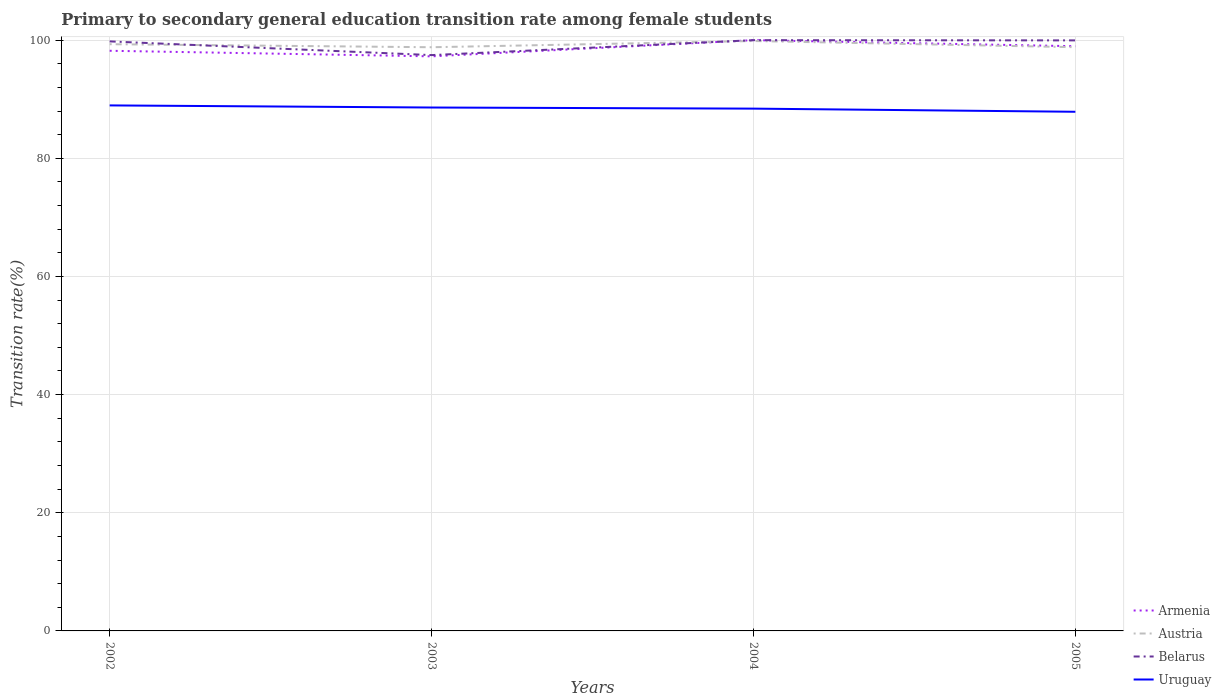Does the line corresponding to Austria intersect with the line corresponding to Armenia?
Your response must be concise. Yes. Is the number of lines equal to the number of legend labels?
Your answer should be compact. Yes. Across all years, what is the maximum transition rate in Belarus?
Ensure brevity in your answer.  97.47. In which year was the transition rate in Uruguay maximum?
Your answer should be compact. 2005. What is the total transition rate in Armenia in the graph?
Provide a succinct answer. 0.95. What is the difference between the highest and the second highest transition rate in Austria?
Provide a succinct answer. 1.05. What is the difference between the highest and the lowest transition rate in Belarus?
Your answer should be very brief. 3. What is the difference between two consecutive major ticks on the Y-axis?
Keep it short and to the point. 20. Does the graph contain any zero values?
Offer a terse response. No. What is the title of the graph?
Your answer should be compact. Primary to secondary general education transition rate among female students. What is the label or title of the Y-axis?
Provide a short and direct response. Transition rate(%). What is the Transition rate(%) in Armenia in 2002?
Your answer should be very brief. 98.2. What is the Transition rate(%) of Austria in 2002?
Ensure brevity in your answer.  99.32. What is the Transition rate(%) of Belarus in 2002?
Ensure brevity in your answer.  99.79. What is the Transition rate(%) of Uruguay in 2002?
Ensure brevity in your answer.  88.96. What is the Transition rate(%) of Armenia in 2003?
Offer a very short reply. 97.26. What is the Transition rate(%) of Austria in 2003?
Provide a succinct answer. 98.8. What is the Transition rate(%) in Belarus in 2003?
Keep it short and to the point. 97.47. What is the Transition rate(%) in Uruguay in 2003?
Provide a short and direct response. 88.6. What is the Transition rate(%) in Austria in 2004?
Ensure brevity in your answer.  99.85. What is the Transition rate(%) in Uruguay in 2004?
Keep it short and to the point. 88.41. What is the Transition rate(%) in Armenia in 2005?
Your answer should be very brief. 98.97. What is the Transition rate(%) in Austria in 2005?
Ensure brevity in your answer.  98.81. What is the Transition rate(%) in Belarus in 2005?
Keep it short and to the point. 99.96. What is the Transition rate(%) in Uruguay in 2005?
Keep it short and to the point. 87.88. Across all years, what is the maximum Transition rate(%) in Armenia?
Ensure brevity in your answer.  100. Across all years, what is the maximum Transition rate(%) of Austria?
Provide a succinct answer. 99.85. Across all years, what is the maximum Transition rate(%) of Belarus?
Your response must be concise. 100. Across all years, what is the maximum Transition rate(%) in Uruguay?
Your answer should be compact. 88.96. Across all years, what is the minimum Transition rate(%) in Armenia?
Your answer should be compact. 97.26. Across all years, what is the minimum Transition rate(%) in Austria?
Your answer should be compact. 98.8. Across all years, what is the minimum Transition rate(%) in Belarus?
Make the answer very short. 97.47. Across all years, what is the minimum Transition rate(%) in Uruguay?
Offer a terse response. 87.88. What is the total Transition rate(%) of Armenia in the graph?
Keep it short and to the point. 394.44. What is the total Transition rate(%) of Austria in the graph?
Offer a very short reply. 396.78. What is the total Transition rate(%) of Belarus in the graph?
Your answer should be very brief. 397.22. What is the total Transition rate(%) in Uruguay in the graph?
Offer a terse response. 353.84. What is the difference between the Transition rate(%) of Armenia in 2002 and that in 2003?
Your answer should be very brief. 0.95. What is the difference between the Transition rate(%) in Austria in 2002 and that in 2003?
Ensure brevity in your answer.  0.52. What is the difference between the Transition rate(%) of Belarus in 2002 and that in 2003?
Make the answer very short. 2.32. What is the difference between the Transition rate(%) in Uruguay in 2002 and that in 2003?
Provide a short and direct response. 0.36. What is the difference between the Transition rate(%) of Armenia in 2002 and that in 2004?
Your answer should be very brief. -1.8. What is the difference between the Transition rate(%) of Austria in 2002 and that in 2004?
Offer a very short reply. -0.54. What is the difference between the Transition rate(%) in Belarus in 2002 and that in 2004?
Give a very brief answer. -0.21. What is the difference between the Transition rate(%) of Uruguay in 2002 and that in 2004?
Offer a very short reply. 0.55. What is the difference between the Transition rate(%) of Armenia in 2002 and that in 2005?
Keep it short and to the point. -0.77. What is the difference between the Transition rate(%) of Austria in 2002 and that in 2005?
Ensure brevity in your answer.  0.51. What is the difference between the Transition rate(%) in Belarus in 2002 and that in 2005?
Ensure brevity in your answer.  -0.17. What is the difference between the Transition rate(%) in Uruguay in 2002 and that in 2005?
Ensure brevity in your answer.  1.08. What is the difference between the Transition rate(%) of Armenia in 2003 and that in 2004?
Your answer should be compact. -2.74. What is the difference between the Transition rate(%) of Austria in 2003 and that in 2004?
Provide a succinct answer. -1.05. What is the difference between the Transition rate(%) in Belarus in 2003 and that in 2004?
Your response must be concise. -2.53. What is the difference between the Transition rate(%) of Uruguay in 2003 and that in 2004?
Keep it short and to the point. 0.19. What is the difference between the Transition rate(%) in Armenia in 2003 and that in 2005?
Ensure brevity in your answer.  -1.72. What is the difference between the Transition rate(%) of Austria in 2003 and that in 2005?
Make the answer very short. -0.01. What is the difference between the Transition rate(%) in Belarus in 2003 and that in 2005?
Keep it short and to the point. -2.49. What is the difference between the Transition rate(%) of Uruguay in 2003 and that in 2005?
Offer a very short reply. 0.72. What is the difference between the Transition rate(%) in Armenia in 2004 and that in 2005?
Your answer should be compact. 1.03. What is the difference between the Transition rate(%) of Austria in 2004 and that in 2005?
Keep it short and to the point. 1.05. What is the difference between the Transition rate(%) of Belarus in 2004 and that in 2005?
Your response must be concise. 0.04. What is the difference between the Transition rate(%) of Uruguay in 2004 and that in 2005?
Your answer should be compact. 0.53. What is the difference between the Transition rate(%) in Armenia in 2002 and the Transition rate(%) in Austria in 2003?
Your answer should be very brief. -0.6. What is the difference between the Transition rate(%) of Armenia in 2002 and the Transition rate(%) of Belarus in 2003?
Keep it short and to the point. 0.73. What is the difference between the Transition rate(%) in Armenia in 2002 and the Transition rate(%) in Uruguay in 2003?
Provide a succinct answer. 9.61. What is the difference between the Transition rate(%) of Austria in 2002 and the Transition rate(%) of Belarus in 2003?
Offer a terse response. 1.85. What is the difference between the Transition rate(%) in Austria in 2002 and the Transition rate(%) in Uruguay in 2003?
Your answer should be compact. 10.72. What is the difference between the Transition rate(%) in Belarus in 2002 and the Transition rate(%) in Uruguay in 2003?
Provide a short and direct response. 11.19. What is the difference between the Transition rate(%) in Armenia in 2002 and the Transition rate(%) in Austria in 2004?
Provide a succinct answer. -1.65. What is the difference between the Transition rate(%) of Armenia in 2002 and the Transition rate(%) of Belarus in 2004?
Your answer should be very brief. -1.8. What is the difference between the Transition rate(%) in Armenia in 2002 and the Transition rate(%) in Uruguay in 2004?
Your response must be concise. 9.79. What is the difference between the Transition rate(%) of Austria in 2002 and the Transition rate(%) of Belarus in 2004?
Provide a succinct answer. -0.68. What is the difference between the Transition rate(%) in Austria in 2002 and the Transition rate(%) in Uruguay in 2004?
Ensure brevity in your answer.  10.91. What is the difference between the Transition rate(%) of Belarus in 2002 and the Transition rate(%) of Uruguay in 2004?
Keep it short and to the point. 11.38. What is the difference between the Transition rate(%) in Armenia in 2002 and the Transition rate(%) in Austria in 2005?
Your response must be concise. -0.6. What is the difference between the Transition rate(%) of Armenia in 2002 and the Transition rate(%) of Belarus in 2005?
Provide a succinct answer. -1.76. What is the difference between the Transition rate(%) of Armenia in 2002 and the Transition rate(%) of Uruguay in 2005?
Your answer should be compact. 10.33. What is the difference between the Transition rate(%) of Austria in 2002 and the Transition rate(%) of Belarus in 2005?
Your response must be concise. -0.64. What is the difference between the Transition rate(%) in Austria in 2002 and the Transition rate(%) in Uruguay in 2005?
Provide a short and direct response. 11.44. What is the difference between the Transition rate(%) of Belarus in 2002 and the Transition rate(%) of Uruguay in 2005?
Provide a succinct answer. 11.91. What is the difference between the Transition rate(%) of Armenia in 2003 and the Transition rate(%) of Austria in 2004?
Provide a short and direct response. -2.6. What is the difference between the Transition rate(%) in Armenia in 2003 and the Transition rate(%) in Belarus in 2004?
Keep it short and to the point. -2.74. What is the difference between the Transition rate(%) in Armenia in 2003 and the Transition rate(%) in Uruguay in 2004?
Offer a terse response. 8.85. What is the difference between the Transition rate(%) of Austria in 2003 and the Transition rate(%) of Belarus in 2004?
Ensure brevity in your answer.  -1.2. What is the difference between the Transition rate(%) in Austria in 2003 and the Transition rate(%) in Uruguay in 2004?
Your answer should be compact. 10.39. What is the difference between the Transition rate(%) of Belarus in 2003 and the Transition rate(%) of Uruguay in 2004?
Ensure brevity in your answer.  9.06. What is the difference between the Transition rate(%) in Armenia in 2003 and the Transition rate(%) in Austria in 2005?
Make the answer very short. -1.55. What is the difference between the Transition rate(%) of Armenia in 2003 and the Transition rate(%) of Belarus in 2005?
Your answer should be very brief. -2.7. What is the difference between the Transition rate(%) in Armenia in 2003 and the Transition rate(%) in Uruguay in 2005?
Offer a terse response. 9.38. What is the difference between the Transition rate(%) in Austria in 2003 and the Transition rate(%) in Belarus in 2005?
Give a very brief answer. -1.16. What is the difference between the Transition rate(%) of Austria in 2003 and the Transition rate(%) of Uruguay in 2005?
Your answer should be very brief. 10.92. What is the difference between the Transition rate(%) in Belarus in 2003 and the Transition rate(%) in Uruguay in 2005?
Ensure brevity in your answer.  9.59. What is the difference between the Transition rate(%) in Armenia in 2004 and the Transition rate(%) in Austria in 2005?
Keep it short and to the point. 1.19. What is the difference between the Transition rate(%) in Armenia in 2004 and the Transition rate(%) in Belarus in 2005?
Your answer should be very brief. 0.04. What is the difference between the Transition rate(%) in Armenia in 2004 and the Transition rate(%) in Uruguay in 2005?
Ensure brevity in your answer.  12.12. What is the difference between the Transition rate(%) in Austria in 2004 and the Transition rate(%) in Belarus in 2005?
Ensure brevity in your answer.  -0.11. What is the difference between the Transition rate(%) of Austria in 2004 and the Transition rate(%) of Uruguay in 2005?
Keep it short and to the point. 11.98. What is the difference between the Transition rate(%) of Belarus in 2004 and the Transition rate(%) of Uruguay in 2005?
Make the answer very short. 12.12. What is the average Transition rate(%) of Armenia per year?
Make the answer very short. 98.61. What is the average Transition rate(%) of Austria per year?
Keep it short and to the point. 99.19. What is the average Transition rate(%) of Belarus per year?
Your answer should be very brief. 99.31. What is the average Transition rate(%) in Uruguay per year?
Your response must be concise. 88.46. In the year 2002, what is the difference between the Transition rate(%) in Armenia and Transition rate(%) in Austria?
Give a very brief answer. -1.11. In the year 2002, what is the difference between the Transition rate(%) in Armenia and Transition rate(%) in Belarus?
Ensure brevity in your answer.  -1.59. In the year 2002, what is the difference between the Transition rate(%) of Armenia and Transition rate(%) of Uruguay?
Your answer should be compact. 9.25. In the year 2002, what is the difference between the Transition rate(%) in Austria and Transition rate(%) in Belarus?
Your answer should be very brief. -0.47. In the year 2002, what is the difference between the Transition rate(%) in Austria and Transition rate(%) in Uruguay?
Provide a short and direct response. 10.36. In the year 2002, what is the difference between the Transition rate(%) of Belarus and Transition rate(%) of Uruguay?
Your answer should be very brief. 10.83. In the year 2003, what is the difference between the Transition rate(%) of Armenia and Transition rate(%) of Austria?
Keep it short and to the point. -1.54. In the year 2003, what is the difference between the Transition rate(%) in Armenia and Transition rate(%) in Belarus?
Offer a very short reply. -0.21. In the year 2003, what is the difference between the Transition rate(%) in Armenia and Transition rate(%) in Uruguay?
Your answer should be compact. 8.66. In the year 2003, what is the difference between the Transition rate(%) of Austria and Transition rate(%) of Belarus?
Keep it short and to the point. 1.33. In the year 2003, what is the difference between the Transition rate(%) in Austria and Transition rate(%) in Uruguay?
Your answer should be compact. 10.2. In the year 2003, what is the difference between the Transition rate(%) of Belarus and Transition rate(%) of Uruguay?
Provide a succinct answer. 8.87. In the year 2004, what is the difference between the Transition rate(%) in Armenia and Transition rate(%) in Austria?
Give a very brief answer. 0.15. In the year 2004, what is the difference between the Transition rate(%) of Armenia and Transition rate(%) of Belarus?
Offer a terse response. 0. In the year 2004, what is the difference between the Transition rate(%) in Armenia and Transition rate(%) in Uruguay?
Ensure brevity in your answer.  11.59. In the year 2004, what is the difference between the Transition rate(%) of Austria and Transition rate(%) of Belarus?
Provide a succinct answer. -0.15. In the year 2004, what is the difference between the Transition rate(%) of Austria and Transition rate(%) of Uruguay?
Your answer should be compact. 11.45. In the year 2004, what is the difference between the Transition rate(%) in Belarus and Transition rate(%) in Uruguay?
Provide a succinct answer. 11.59. In the year 2005, what is the difference between the Transition rate(%) of Armenia and Transition rate(%) of Austria?
Provide a succinct answer. 0.17. In the year 2005, what is the difference between the Transition rate(%) of Armenia and Transition rate(%) of Belarus?
Provide a short and direct response. -0.99. In the year 2005, what is the difference between the Transition rate(%) in Armenia and Transition rate(%) in Uruguay?
Keep it short and to the point. 11.1. In the year 2005, what is the difference between the Transition rate(%) in Austria and Transition rate(%) in Belarus?
Your answer should be compact. -1.15. In the year 2005, what is the difference between the Transition rate(%) in Austria and Transition rate(%) in Uruguay?
Ensure brevity in your answer.  10.93. In the year 2005, what is the difference between the Transition rate(%) in Belarus and Transition rate(%) in Uruguay?
Your answer should be very brief. 12.08. What is the ratio of the Transition rate(%) of Armenia in 2002 to that in 2003?
Your answer should be very brief. 1.01. What is the ratio of the Transition rate(%) of Belarus in 2002 to that in 2003?
Provide a succinct answer. 1.02. What is the ratio of the Transition rate(%) in Armenia in 2002 to that in 2004?
Your answer should be very brief. 0.98. What is the ratio of the Transition rate(%) in Belarus in 2002 to that in 2004?
Your response must be concise. 1. What is the ratio of the Transition rate(%) in Uruguay in 2002 to that in 2004?
Provide a succinct answer. 1.01. What is the ratio of the Transition rate(%) of Armenia in 2002 to that in 2005?
Ensure brevity in your answer.  0.99. What is the ratio of the Transition rate(%) of Austria in 2002 to that in 2005?
Provide a succinct answer. 1.01. What is the ratio of the Transition rate(%) in Belarus in 2002 to that in 2005?
Provide a succinct answer. 1. What is the ratio of the Transition rate(%) in Uruguay in 2002 to that in 2005?
Offer a very short reply. 1.01. What is the ratio of the Transition rate(%) in Armenia in 2003 to that in 2004?
Offer a terse response. 0.97. What is the ratio of the Transition rate(%) of Belarus in 2003 to that in 2004?
Offer a terse response. 0.97. What is the ratio of the Transition rate(%) in Armenia in 2003 to that in 2005?
Offer a very short reply. 0.98. What is the ratio of the Transition rate(%) of Austria in 2003 to that in 2005?
Ensure brevity in your answer.  1. What is the ratio of the Transition rate(%) in Belarus in 2003 to that in 2005?
Offer a terse response. 0.98. What is the ratio of the Transition rate(%) in Uruguay in 2003 to that in 2005?
Ensure brevity in your answer.  1.01. What is the ratio of the Transition rate(%) of Armenia in 2004 to that in 2005?
Give a very brief answer. 1.01. What is the ratio of the Transition rate(%) of Austria in 2004 to that in 2005?
Ensure brevity in your answer.  1.01. What is the ratio of the Transition rate(%) in Uruguay in 2004 to that in 2005?
Your answer should be very brief. 1.01. What is the difference between the highest and the second highest Transition rate(%) in Armenia?
Ensure brevity in your answer.  1.03. What is the difference between the highest and the second highest Transition rate(%) in Austria?
Give a very brief answer. 0.54. What is the difference between the highest and the second highest Transition rate(%) in Belarus?
Give a very brief answer. 0.04. What is the difference between the highest and the second highest Transition rate(%) in Uruguay?
Provide a succinct answer. 0.36. What is the difference between the highest and the lowest Transition rate(%) of Armenia?
Keep it short and to the point. 2.74. What is the difference between the highest and the lowest Transition rate(%) of Austria?
Your response must be concise. 1.05. What is the difference between the highest and the lowest Transition rate(%) of Belarus?
Make the answer very short. 2.53. What is the difference between the highest and the lowest Transition rate(%) in Uruguay?
Give a very brief answer. 1.08. 